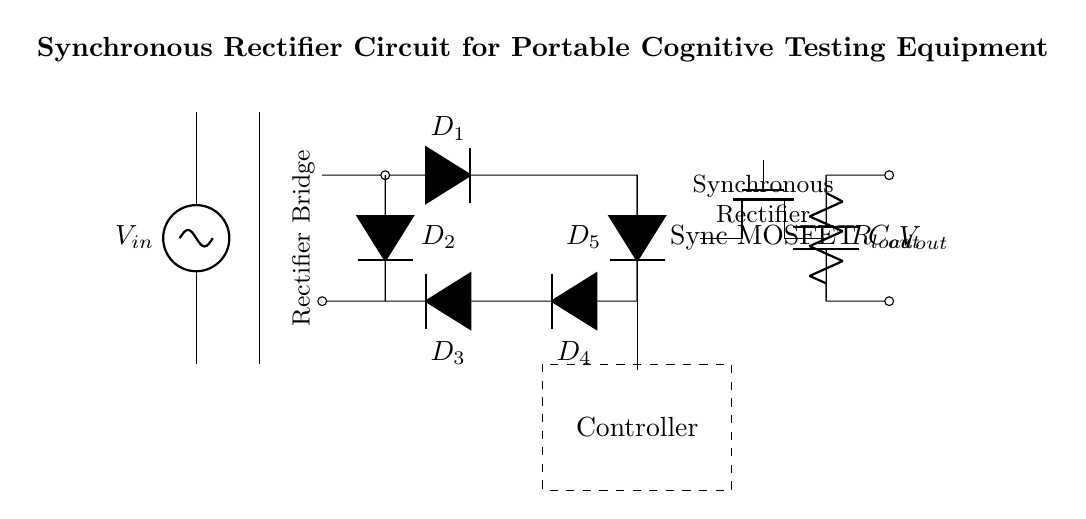What is the input source of this rectifier circuit? The input source is labeled as V_in, which represents the voltage source that supplies alternating current to the circuit.
Answer: V_in How many diodes are used in the rectifier bridge? The rectifier bridge includes four diodes, as indicated by the labels D1, D2, D3, and D4 in the diagram.
Answer: Four What type of MOSFET is used for synchronous rectification? The circuit employs a specific type of MOSFET referred to as Sync MOSFET, indicated in the diagram with a label.
Answer: Sync MOSFET What does the dashed rectangle symbolize in the circuit? The dashed rectangle represents the controller, which is responsible for managing the synchronous rectification process and controlling the operation of the MOSFET.
Answer: Controller What is the purpose of the output capacitor in this circuit? The output capacitor, labeled as C_out, is used to smooth the output voltage by filtering out the fluctuations caused by the rectification process, providing a more stable signal to the load.
Answer: Smooth output voltage How does the synchronous rectifier improve efficiency compared to a standard rectifier? The synchronous rectifier minimizes the voltage drop across the conducting device (the MOSFET in this case), leading to lower power loss and higher overall efficiency, particularly in low-voltage applications like portable devices.
Answer: Improves efficiency What is the load component labeled in the circuit? The load component is labeled as R_load, which represents the resistor that simulates the load in the circuit, where the power is being delivered.
Answer: R_load 